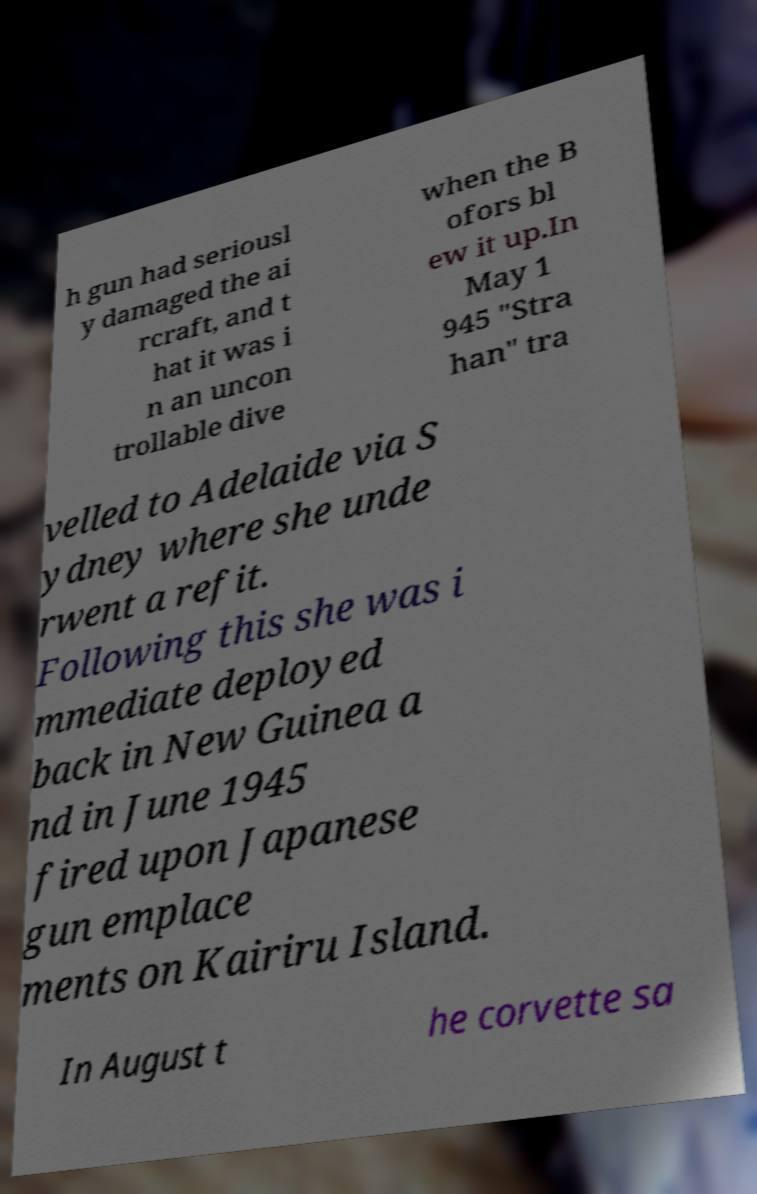Can you read and provide the text displayed in the image?This photo seems to have some interesting text. Can you extract and type it out for me? h gun had seriousl y damaged the ai rcraft, and t hat it was i n an uncon trollable dive when the B ofors bl ew it up.In May 1 945 "Stra han" tra velled to Adelaide via S ydney where she unde rwent a refit. Following this she was i mmediate deployed back in New Guinea a nd in June 1945 fired upon Japanese gun emplace ments on Kairiru Island. In August t he corvette sa 